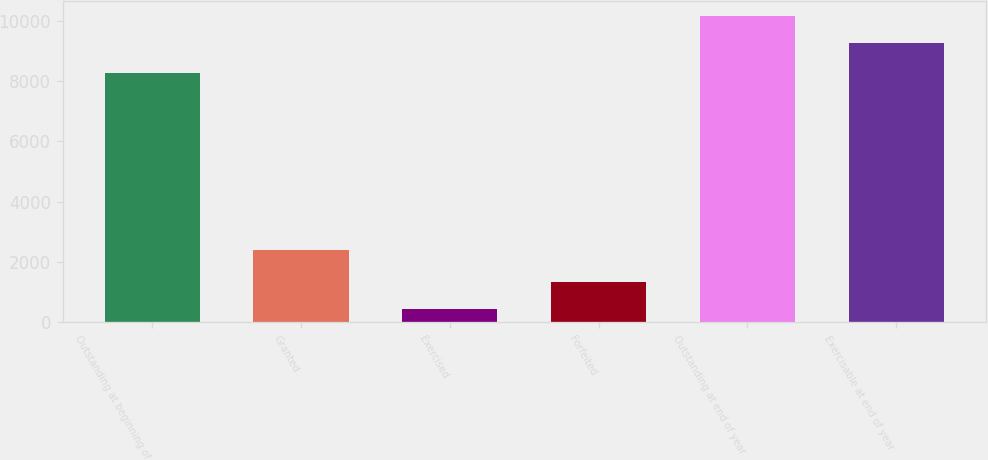<chart> <loc_0><loc_0><loc_500><loc_500><bar_chart><fcel>Outstanding at beginning of<fcel>Granted<fcel>Exercised<fcel>Forfeited<fcel>Outstanding at end of year<fcel>Exercisable at end of year<nl><fcel>8255<fcel>2405<fcel>433<fcel>1329.9<fcel>10145.9<fcel>9249<nl></chart> 